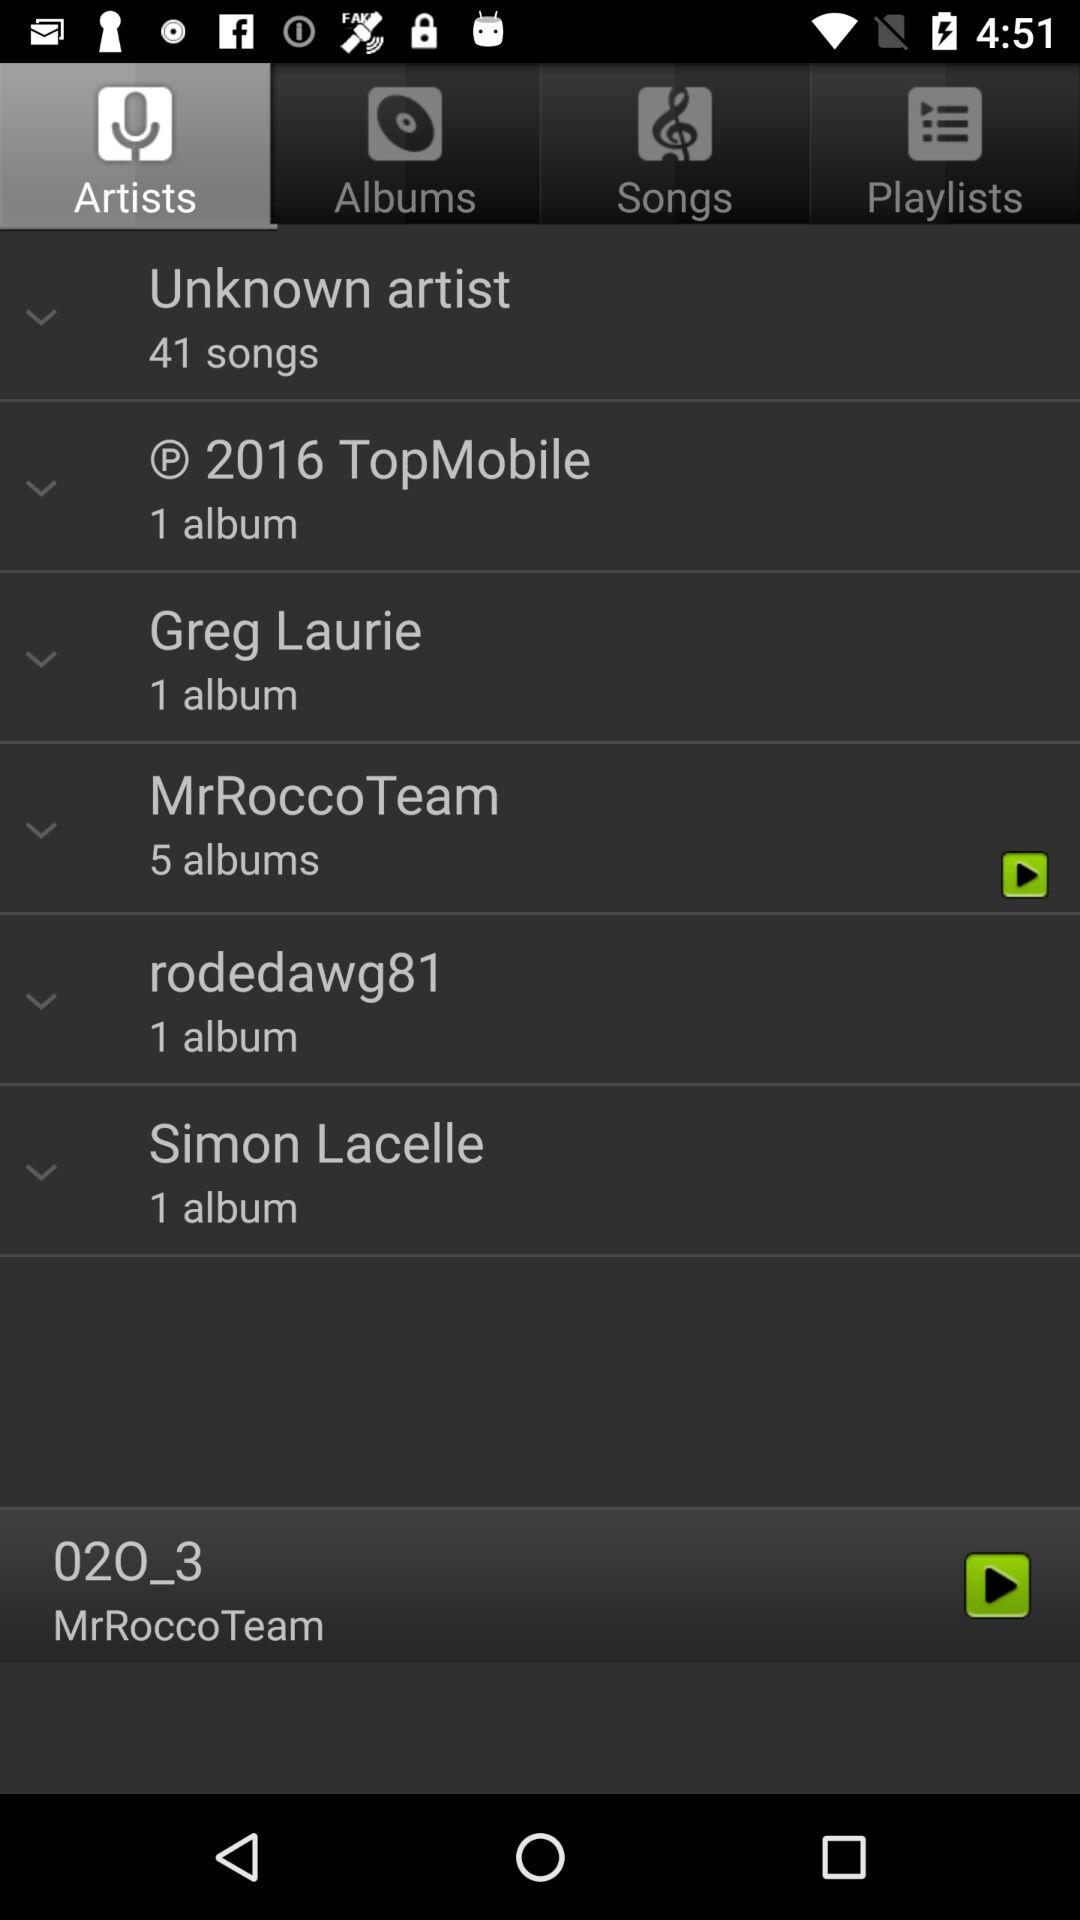Who is the artist of "02O_3"? The artist of "02O_3" is "MrRocco Team". 